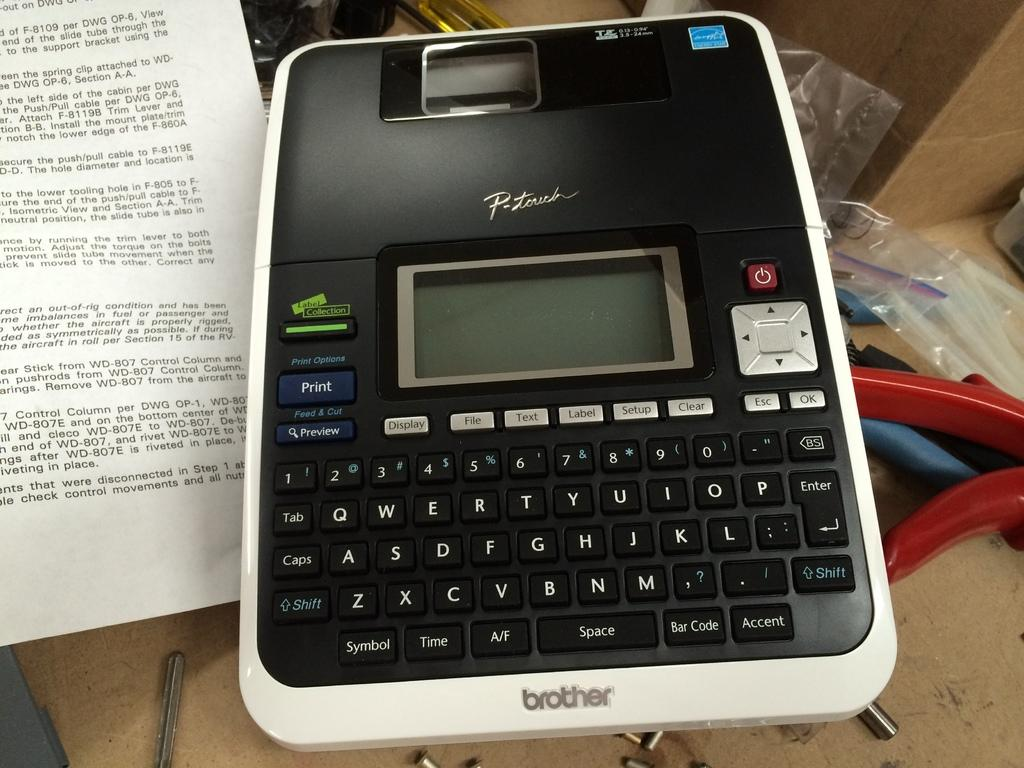<image>
Provide a brief description of the given image. A desktop labeler by Brother called "P-Touch" is sitting on a table. 